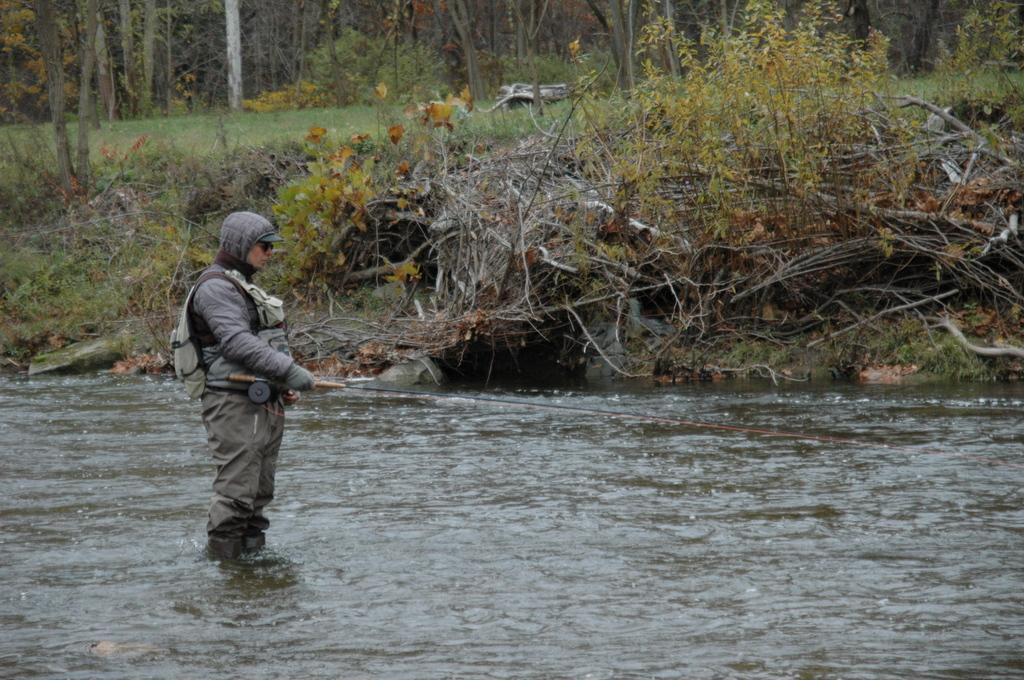Could you give a brief overview of what you see in this image? In this image we can see a person standing in the water and holding a stick. In the background, we can see the trees and grass. 